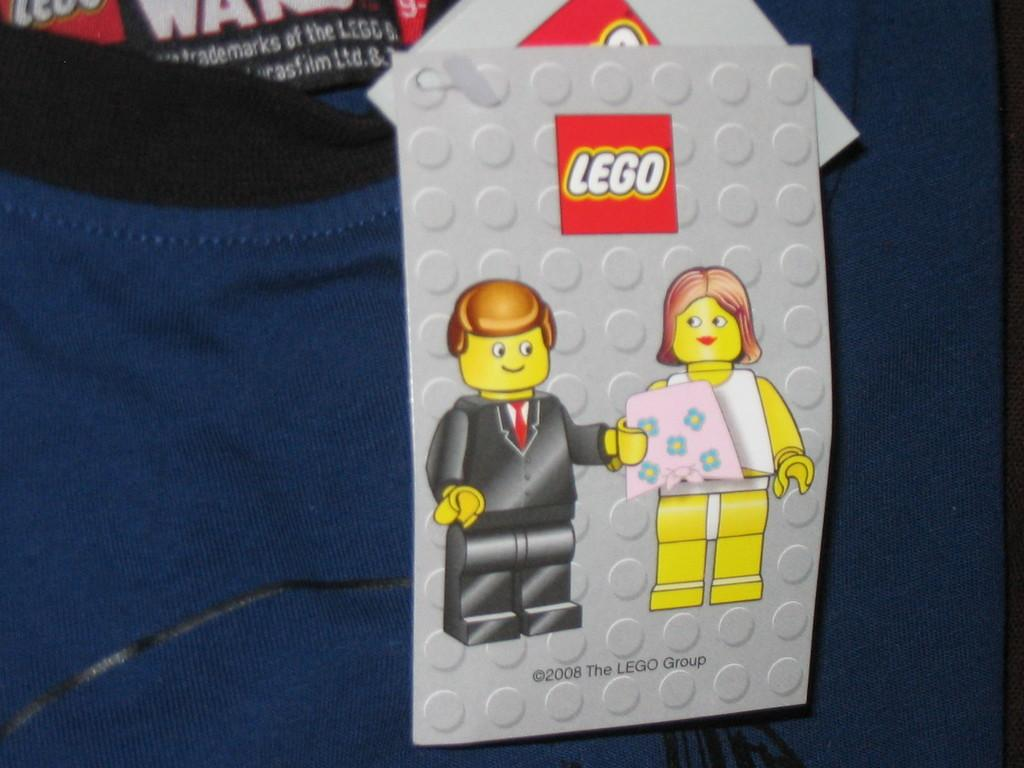<image>
Describe the image concisely. A Lego card showing a Lego man giving Lego woman a gift. 